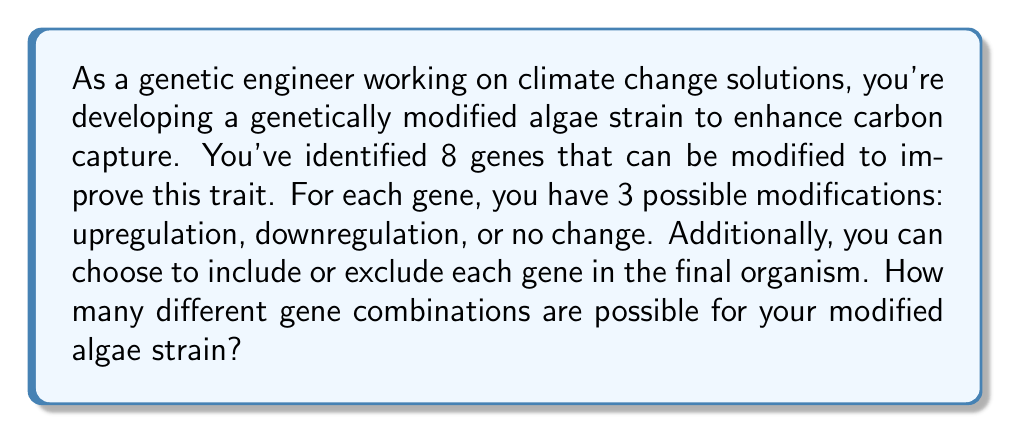Help me with this question. Let's approach this problem step-by-step:

1) For each gene, we have 4 possibilities:
   - Upregulation
   - Downregulation
   - No change
   - Exclusion from the final organism

2) We can represent this as having 4 choices for each of the 8 genes.

3) This is a case of the multiplication principle. When we have a series of independent choices, we multiply the number of options for each choice.

4) Therefore, the total number of possible combinations is:

   $$ 4^8 $$

5) Let's calculate this:
   $$ 4^8 = 4 \times 4 \times 4 \times 4 \times 4 \times 4 \times 4 \times 4 = 65,536 $$

Thus, there are 65,536 possible gene combinations for the modified algae strain.
Answer: $65,536$ possible gene combinations 